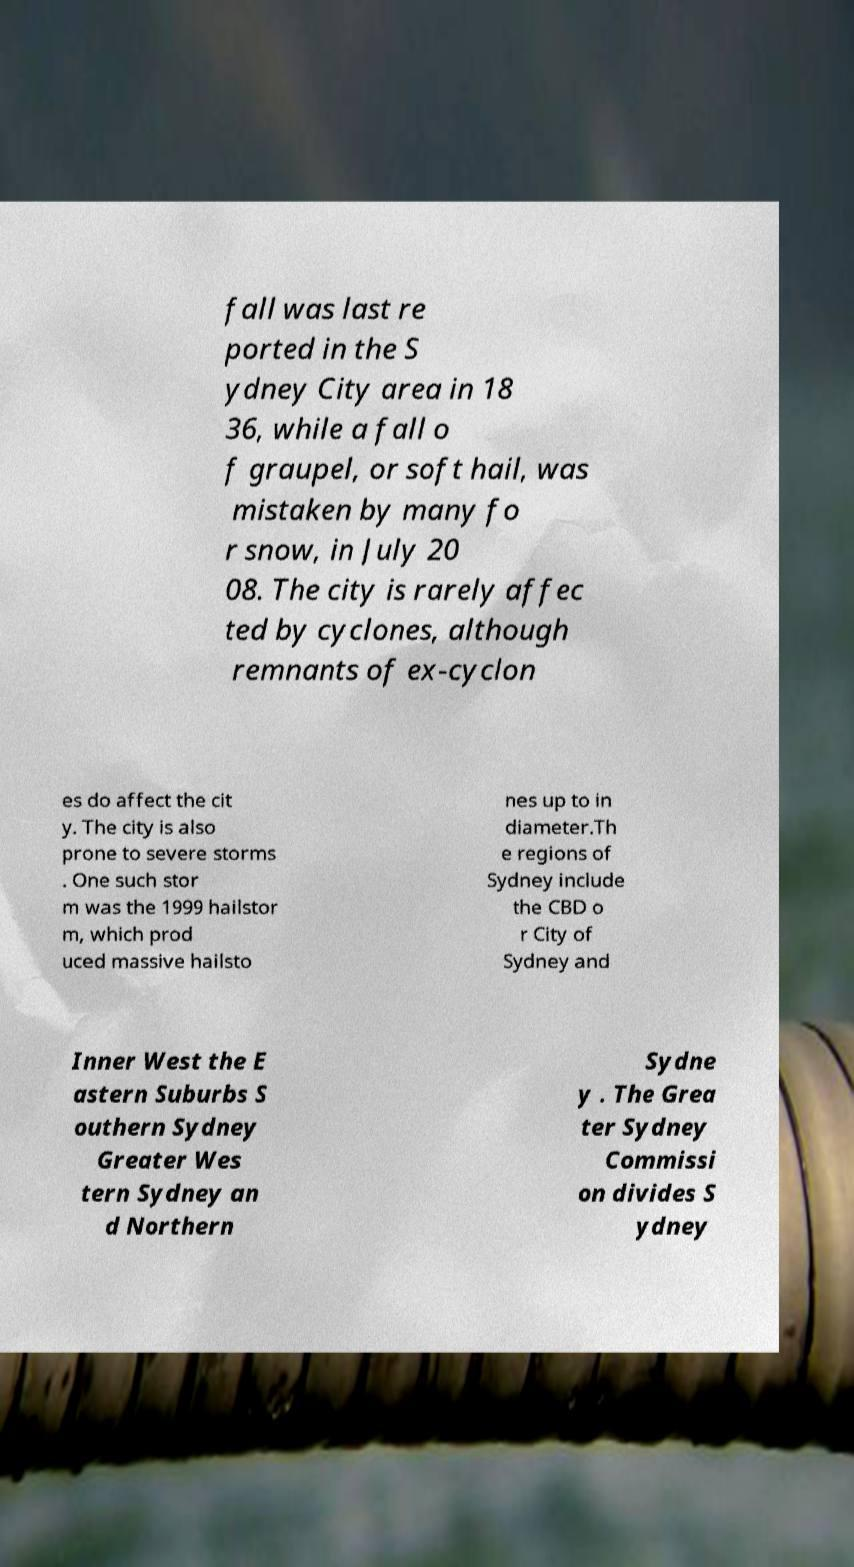Can you accurately transcribe the text from the provided image for me? fall was last re ported in the S ydney City area in 18 36, while a fall o f graupel, or soft hail, was mistaken by many fo r snow, in July 20 08. The city is rarely affec ted by cyclones, although remnants of ex-cyclon es do affect the cit y. The city is also prone to severe storms . One such stor m was the 1999 hailstor m, which prod uced massive hailsto nes up to in diameter.Th e regions of Sydney include the CBD o r City of Sydney and Inner West the E astern Suburbs S outhern Sydney Greater Wes tern Sydney an d Northern Sydne y . The Grea ter Sydney Commissi on divides S ydney 